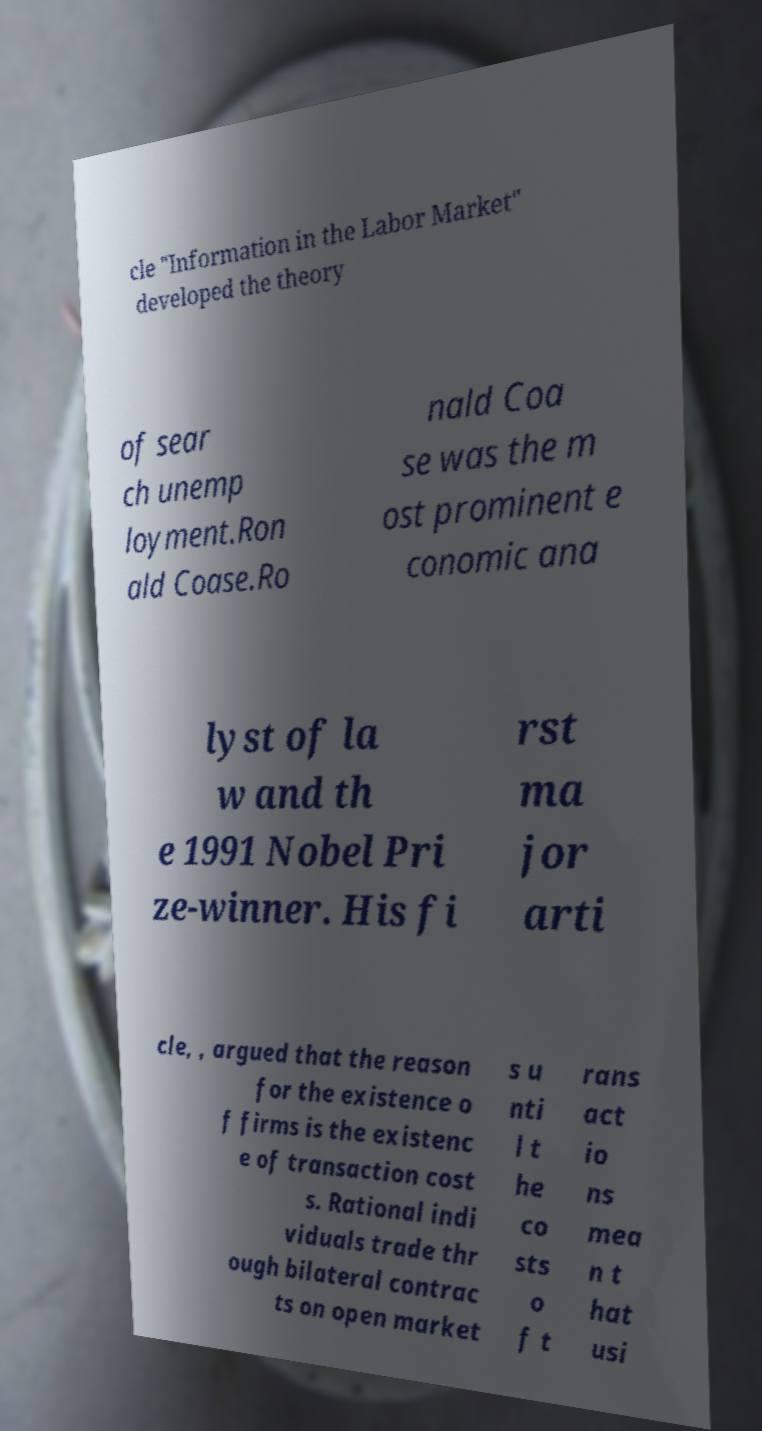I need the written content from this picture converted into text. Can you do that? cle "Information in the Labor Market" developed the theory of sear ch unemp loyment.Ron ald Coase.Ro nald Coa se was the m ost prominent e conomic ana lyst of la w and th e 1991 Nobel Pri ze-winner. His fi rst ma jor arti cle, , argued that the reason for the existence o f firms is the existenc e of transaction cost s. Rational indi viduals trade thr ough bilateral contrac ts on open market s u nti l t he co sts o f t rans act io ns mea n t hat usi 